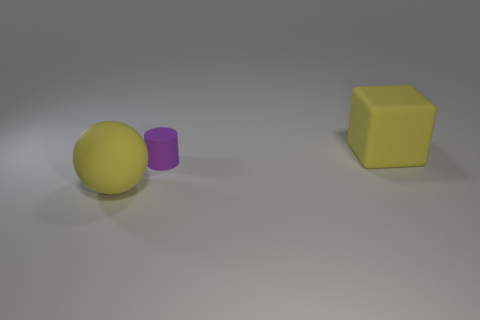Add 3 large cubes. How many objects exist? 6 Subtract all spheres. How many objects are left? 2 Subtract all large yellow balls. Subtract all tiny yellow objects. How many objects are left? 2 Add 1 big yellow balls. How many big yellow balls are left? 2 Add 2 yellow balls. How many yellow balls exist? 3 Subtract 1 yellow spheres. How many objects are left? 2 